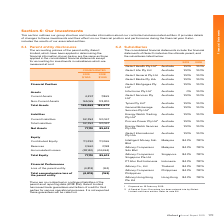According to Iselect's financial document, What is the current assets of the parent entity in 2019? According to the financial document, 4,297 (in thousands). The relevant text states: "Current Assets 4,297 7,869..." Also, What is the non-current assets of the parent entity in 2018? According to the financial document, 174,810 (in thousands). The relevant text states: "Non-Current Assets 165,165 174,810..." Also, What is the loss of the parent entity in 2019? According to the financial document, 4,812 (in thousands). The relevant text states: "Loss of the parent entity (4,812) (163)..." Also, can you calculate: What is the current ratio of the parent entity in 2019? Based on the calculation: 4,297/92,352, the result is 0.05. This is based on the information: "Current Assets 4,297 7,869 Current Liabilities 92,352 93,067..." The key data points involved are: 4,297, 92,352. Also, can you calculate: What is the debts to assets ratio of the parent entity in 2018? Based on the calculation: 93,067/182,679, the result is 0.51. This is based on the information: "Current Liabilities 92,352 93,067 Total Assets 169,462 182,679..." The key data points involved are: 182,679, 93,067. Also, can you calculate: What is the percentage change in the total comprehensive loss of the parent entity from 2018 to 2019? To answer this question, I need to perform calculations using the financial data. The calculation is: (4,812-163)/163, which equals 2852.15 (percentage). This is based on the information: "Loss of the parent entity (4,812) (163) Loss of the parent entity (4,812) (163)..." The key data points involved are: 163, 4,812. 